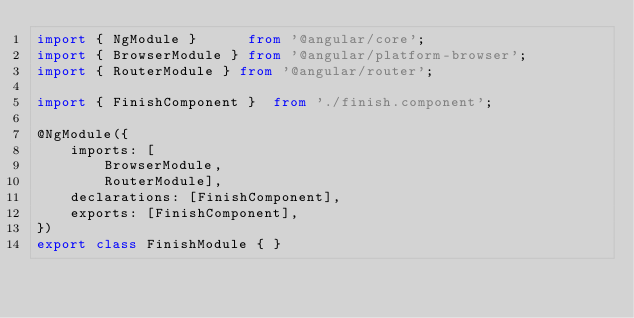<code> <loc_0><loc_0><loc_500><loc_500><_TypeScript_>import { NgModule }      from '@angular/core';
import { BrowserModule } from '@angular/platform-browser';
import { RouterModule } from '@angular/router';

import { FinishComponent }  from './finish.component';

@NgModule({
    imports: [
        BrowserModule,
        RouterModule],
    declarations: [FinishComponent],
    exports: [FinishComponent],
})
export class FinishModule { }
</code> 